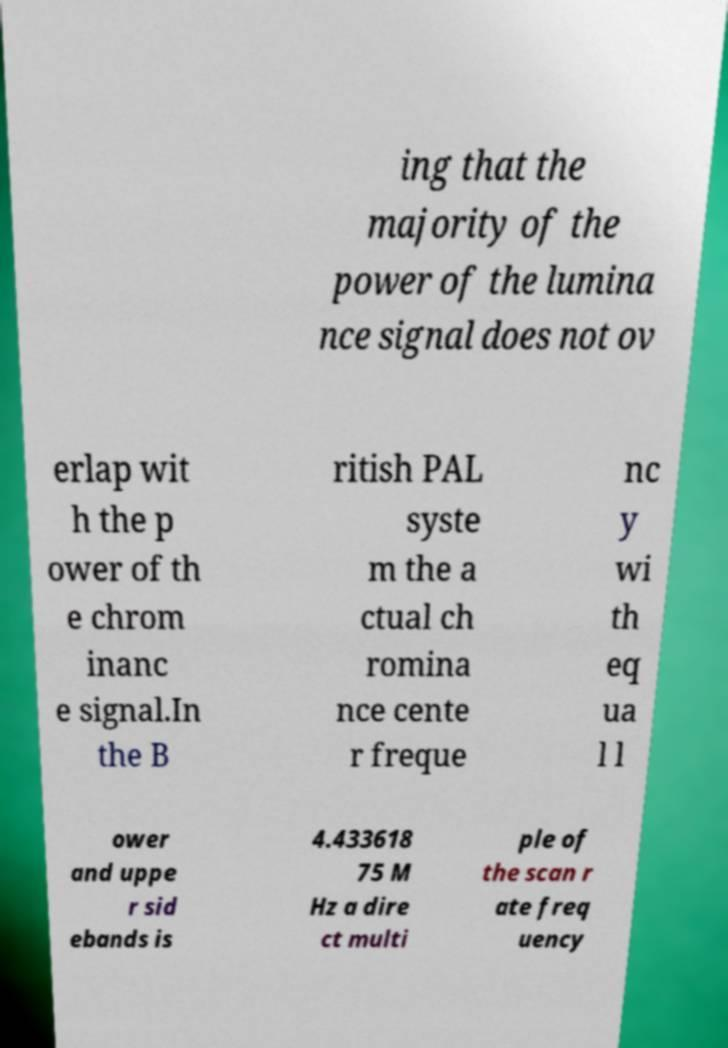There's text embedded in this image that I need extracted. Can you transcribe it verbatim? ing that the majority of the power of the lumina nce signal does not ov erlap wit h the p ower of th e chrom inanc e signal.In the B ritish PAL syste m the a ctual ch romina nce cente r freque nc y wi th eq ua l l ower and uppe r sid ebands is 4.433618 75 M Hz a dire ct multi ple of the scan r ate freq uency 